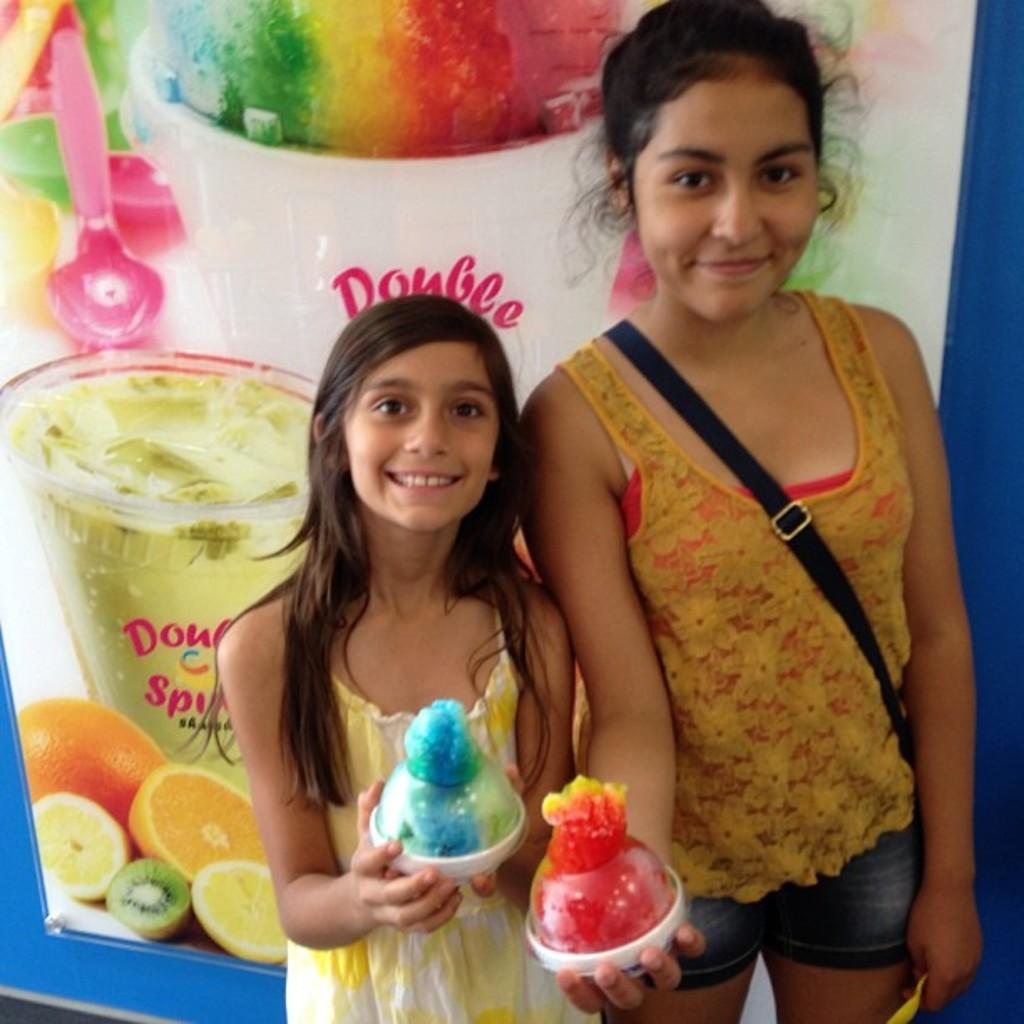How many people are in the image? There are two women in the image. What expressions do the women have? The women are smiling. What are the women holding in the image? The women are holding objects. What can be seen in the background of the image? There is a poster in the background of the image. What type of yoke is being used by the manager in the image? There is no yoke or manager present in the image. What type of beef is being served at the event in the image? There is no event or beef present in the image. 